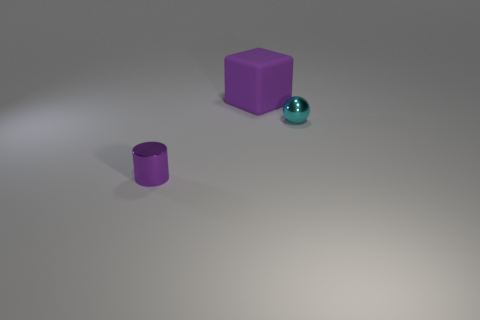Add 1 big purple objects. How many objects exist? 4 Subtract all spheres. How many objects are left? 2 Subtract 1 cylinders. How many cylinders are left? 0 Subtract 0 brown blocks. How many objects are left? 3 Subtract all gray balls. Subtract all purple cubes. How many balls are left? 1 Subtract all gray cubes. How many blue cylinders are left? 0 Subtract all cyan balls. Subtract all tiny cyan rubber cubes. How many objects are left? 2 Add 1 small purple metal things. How many small purple metal things are left? 2 Add 3 gray blocks. How many gray blocks exist? 3 